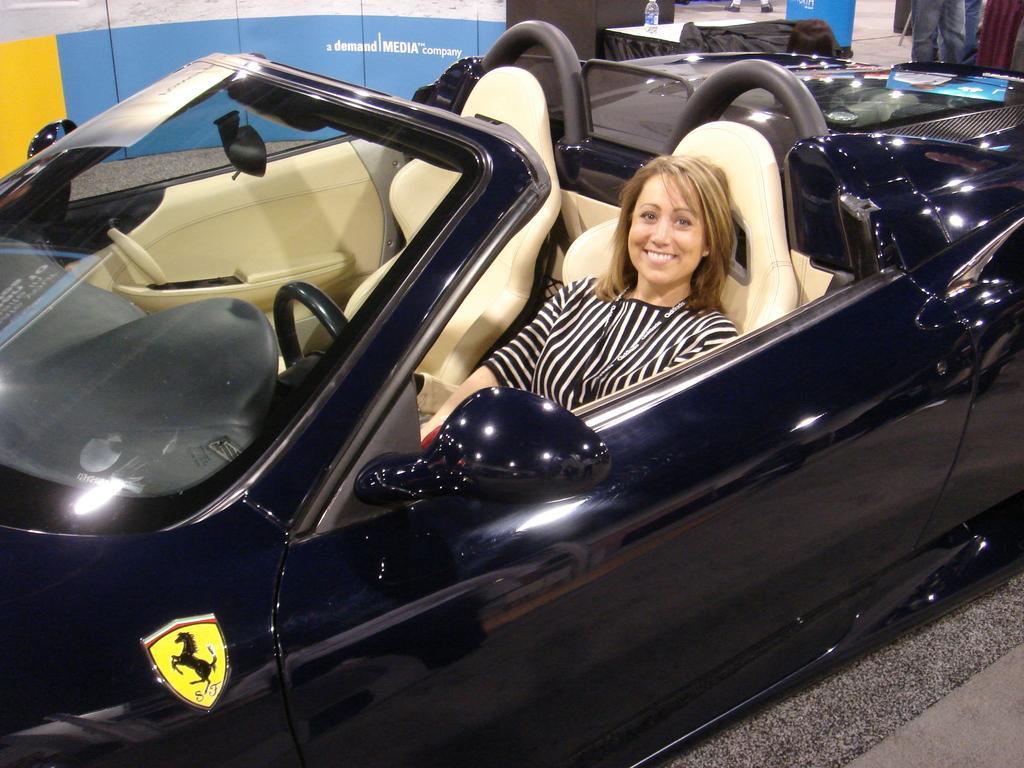In one or two sentences, can you explain what this image depicts? There is a woman sitting inside a car in the foreground area of the image, it seems like a desk, poster and a person in the background. 